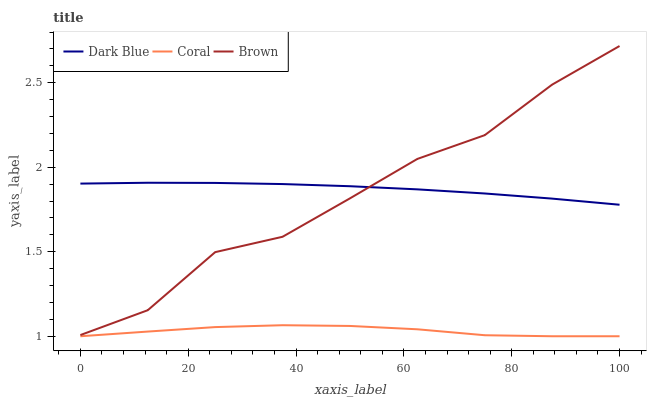Does Coral have the minimum area under the curve?
Answer yes or no. Yes. Does Dark Blue have the maximum area under the curve?
Answer yes or no. Yes. Does Brown have the minimum area under the curve?
Answer yes or no. No. Does Brown have the maximum area under the curve?
Answer yes or no. No. Is Dark Blue the smoothest?
Answer yes or no. Yes. Is Brown the roughest?
Answer yes or no. Yes. Is Coral the smoothest?
Answer yes or no. No. Is Coral the roughest?
Answer yes or no. No. Does Coral have the lowest value?
Answer yes or no. Yes. Does Brown have the lowest value?
Answer yes or no. No. Does Brown have the highest value?
Answer yes or no. Yes. Does Coral have the highest value?
Answer yes or no. No. Is Coral less than Dark Blue?
Answer yes or no. Yes. Is Brown greater than Coral?
Answer yes or no. Yes. Does Dark Blue intersect Brown?
Answer yes or no. Yes. Is Dark Blue less than Brown?
Answer yes or no. No. Is Dark Blue greater than Brown?
Answer yes or no. No. Does Coral intersect Dark Blue?
Answer yes or no. No. 